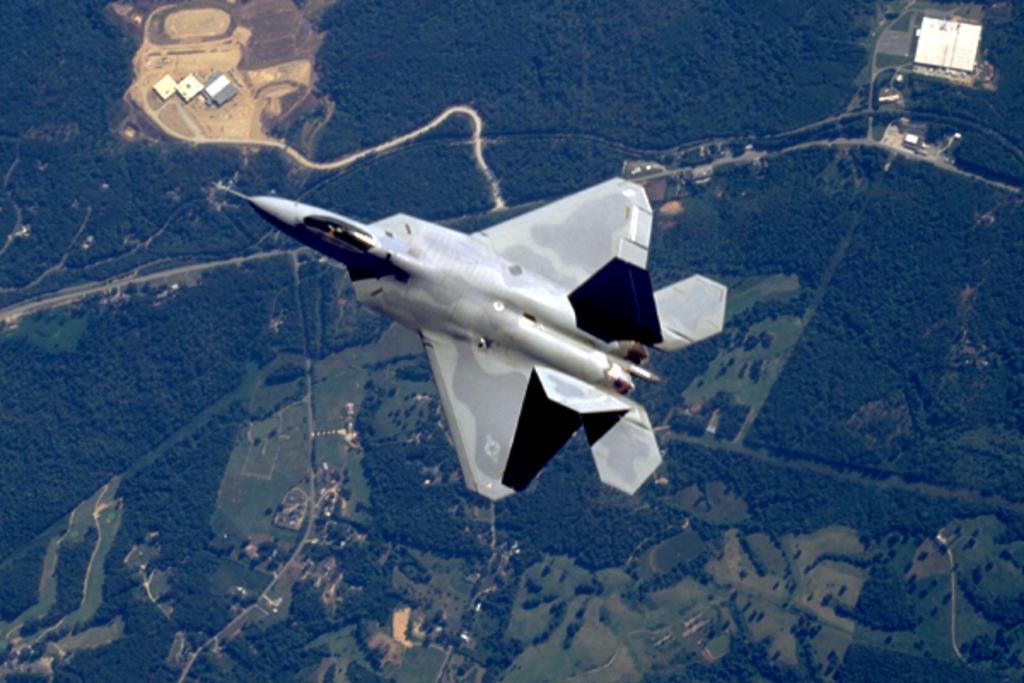In one or two sentences, can you explain what this image depicts? In the image there is a plane. Behind the plane there is a top view of the earth. On the earth there are trees and buildings. 